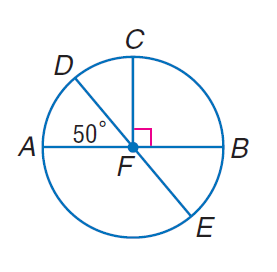Answer the mathemtical geometry problem and directly provide the correct option letter.
Question: In \odot F, m \angle D F A = 50 and C F \perp F B. Find m \widehat C B E.
Choices: A: 40 B: 45 C: 90 D: 140 D 